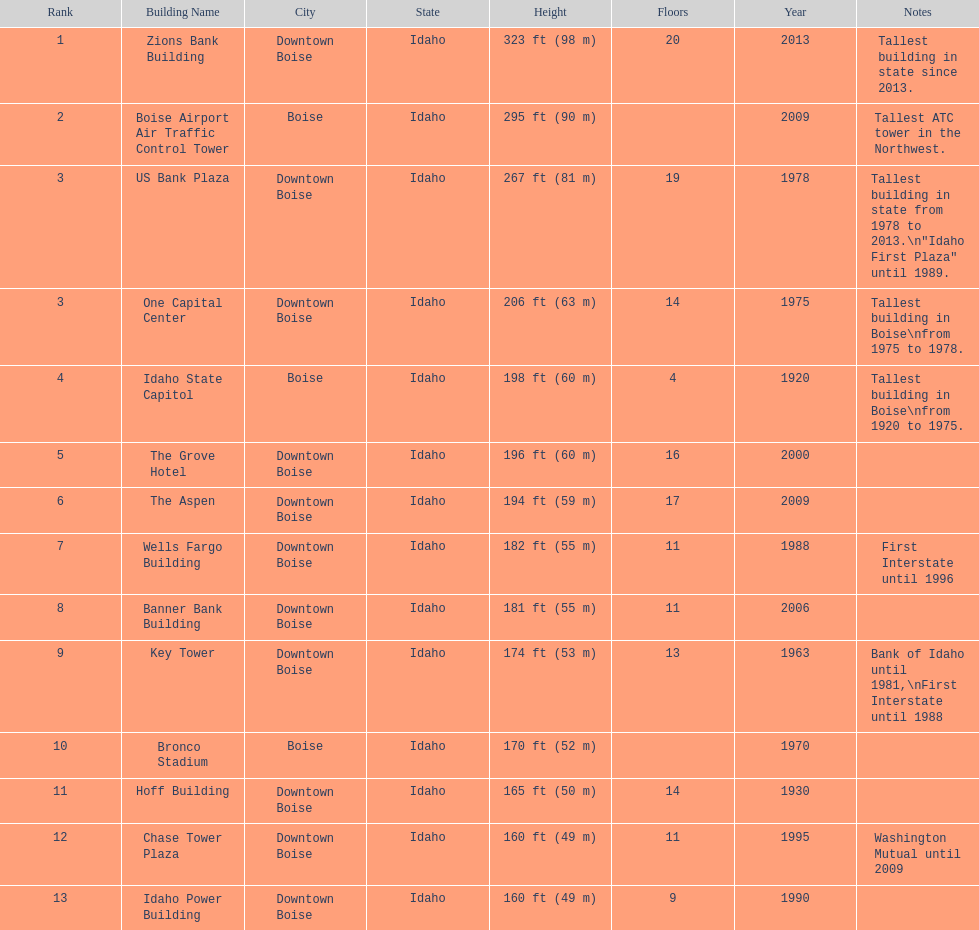What is the tallest building in bosie, idaho? Zions Bank Building Zions Bank Building in Downtown Boise, Idaho. 